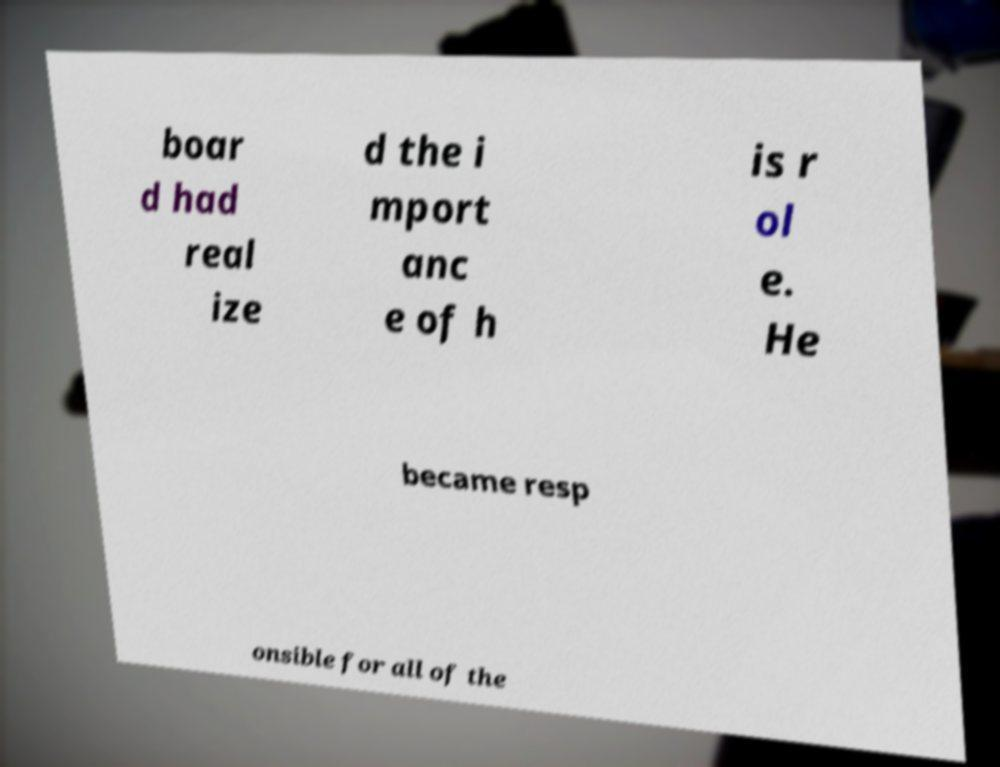Could you assist in decoding the text presented in this image and type it out clearly? boar d had real ize d the i mport anc e of h is r ol e. He became resp onsible for all of the 